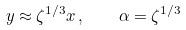Convert formula to latex. <formula><loc_0><loc_0><loc_500><loc_500>y \approx \zeta ^ { 1 / 3 } x \, , \quad \alpha = \zeta ^ { 1 / 3 }</formula> 